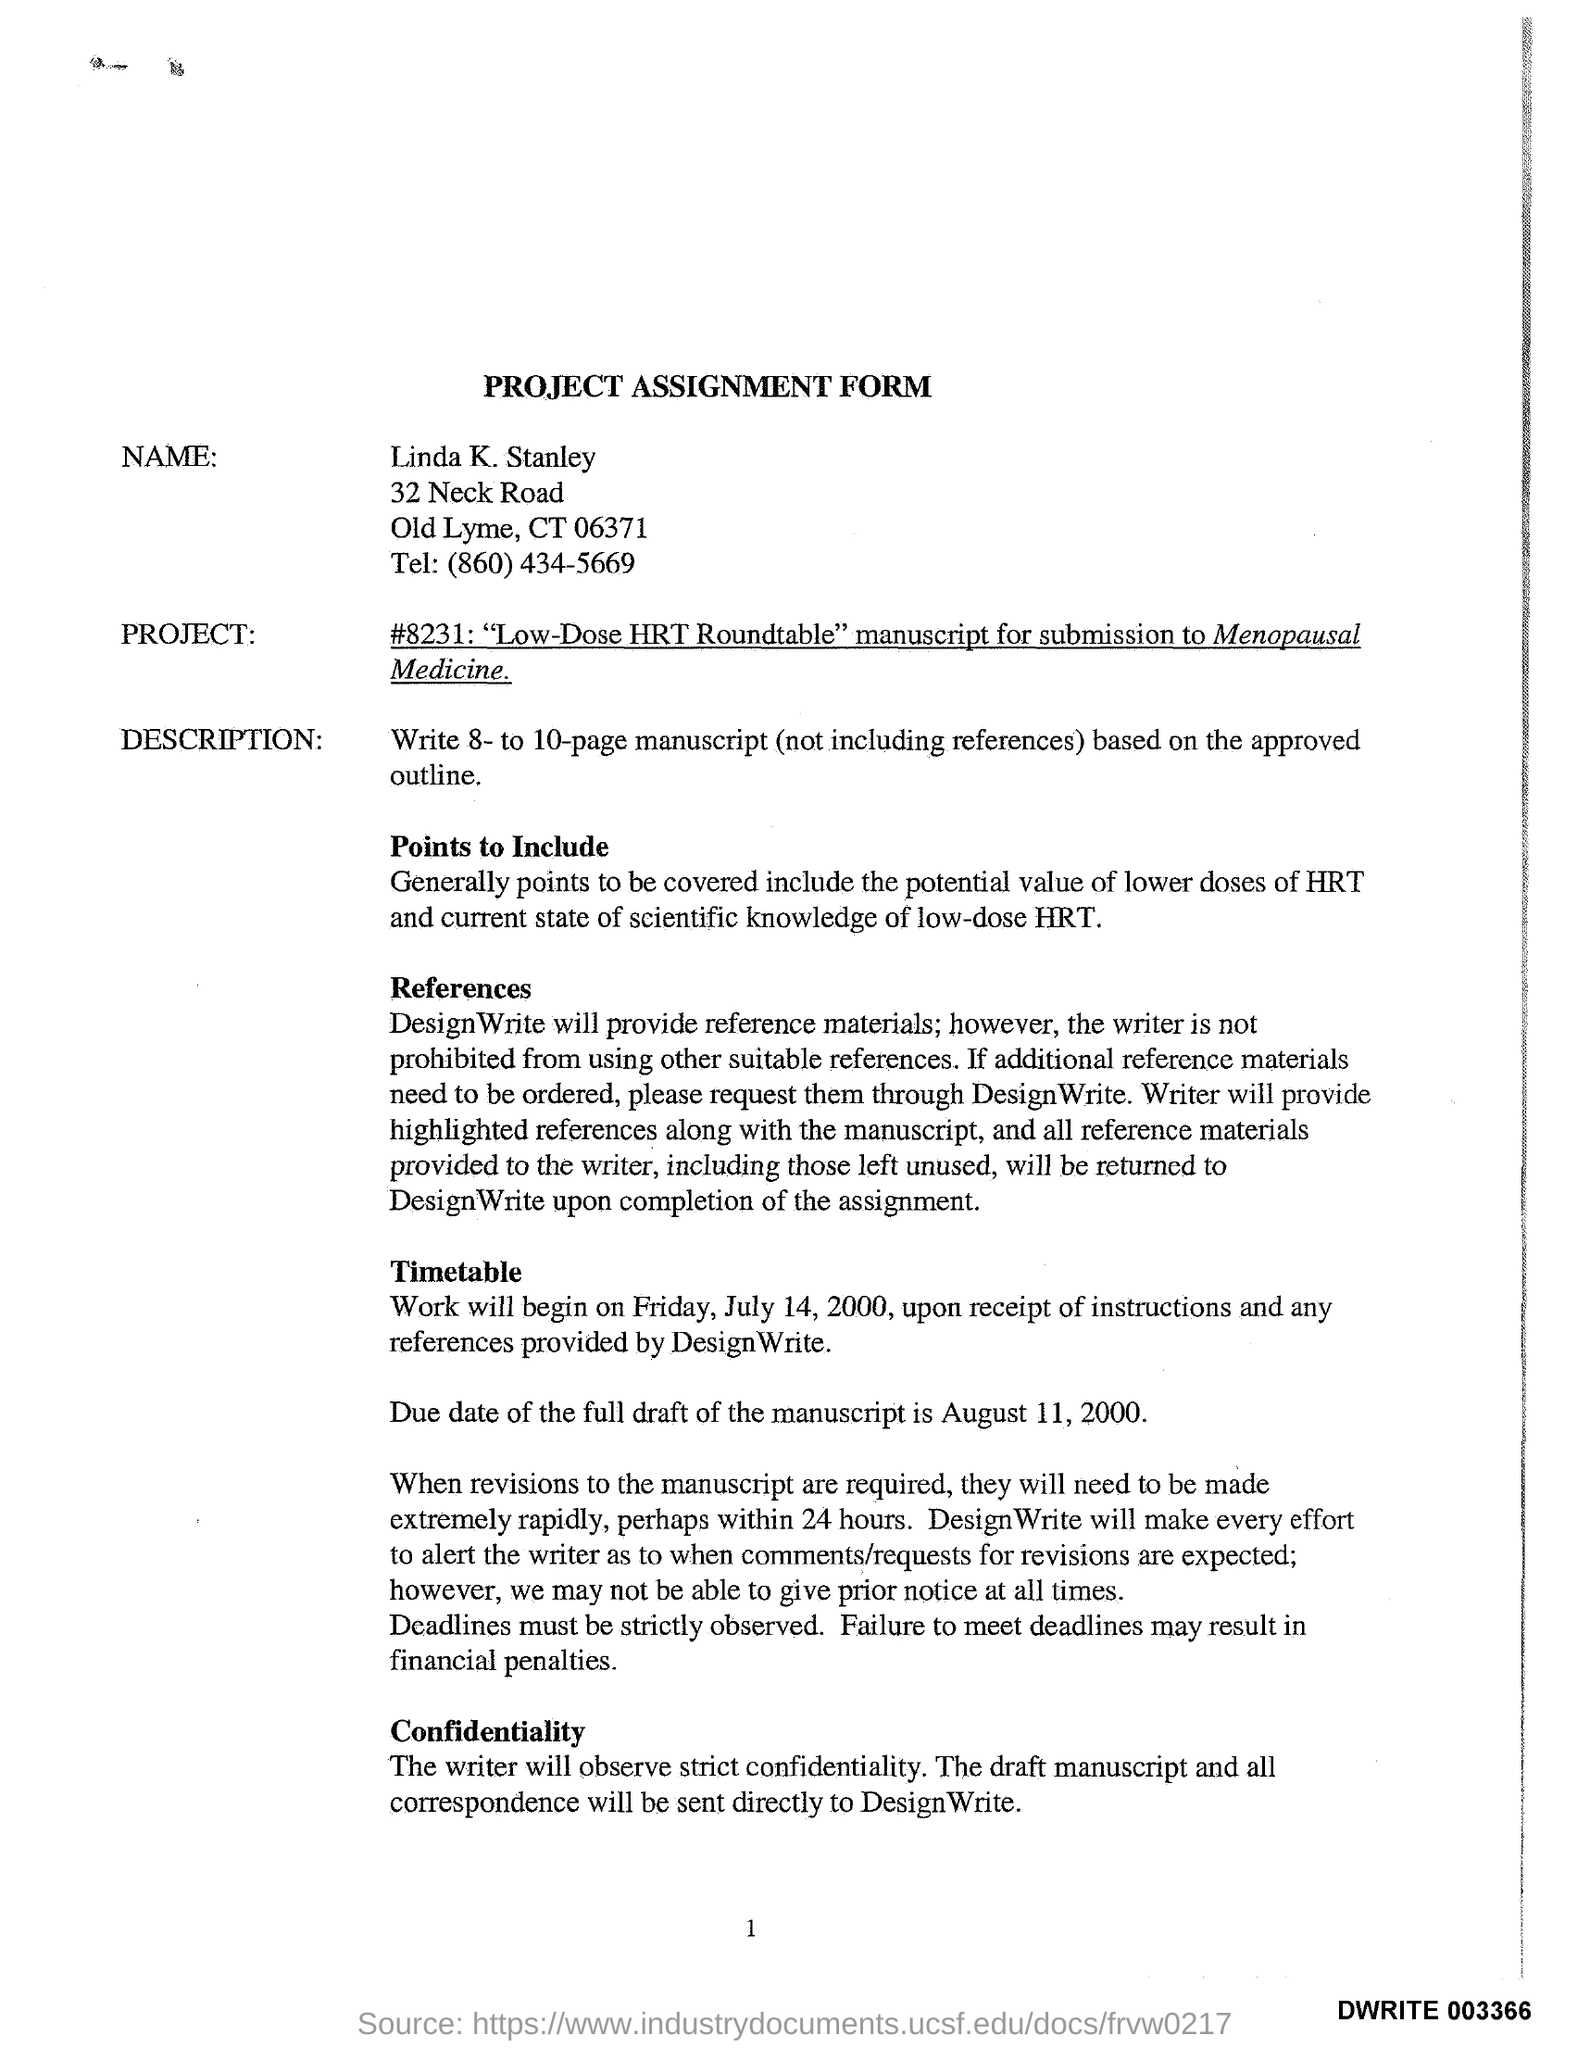What type of Form is this?
Offer a very short reply. Project Assignment form. What is the name mentioned in the form?
Make the answer very short. Linda K. Stanley. 